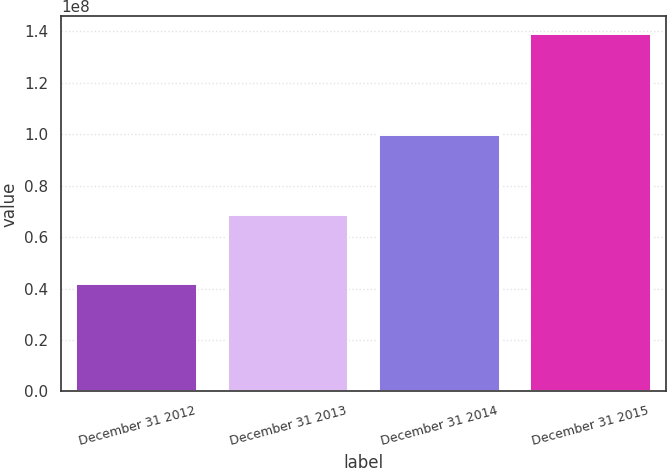<chart> <loc_0><loc_0><loc_500><loc_500><bar_chart><fcel>December 31 2012<fcel>December 31 2013<fcel>December 31 2014<fcel>December 31 2015<nl><fcel>4.17405e+07<fcel>6.85868e+07<fcel>9.98456e+07<fcel>1.38812e+08<nl></chart> 